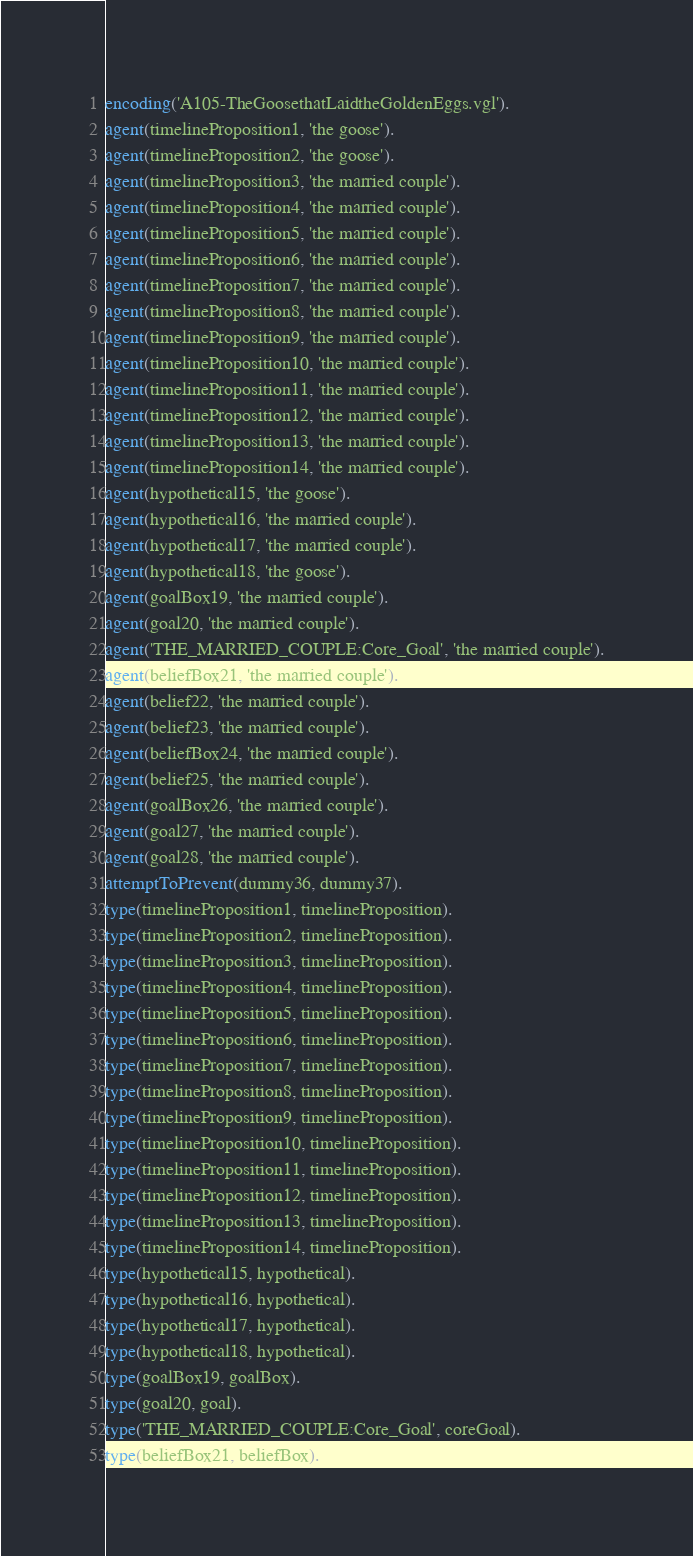<code> <loc_0><loc_0><loc_500><loc_500><_Prolog_>encoding('A105-TheGoosethatLaidtheGoldenEggs.vgl').
agent(timelineProposition1, 'the goose').
agent(timelineProposition2, 'the goose').
agent(timelineProposition3, 'the married couple').
agent(timelineProposition4, 'the married couple').
agent(timelineProposition5, 'the married couple').
agent(timelineProposition6, 'the married couple').
agent(timelineProposition7, 'the married couple').
agent(timelineProposition8, 'the married couple').
agent(timelineProposition9, 'the married couple').
agent(timelineProposition10, 'the married couple').
agent(timelineProposition11, 'the married couple').
agent(timelineProposition12, 'the married couple').
agent(timelineProposition13, 'the married couple').
agent(timelineProposition14, 'the married couple').
agent(hypothetical15, 'the goose').
agent(hypothetical16, 'the married couple').
agent(hypothetical17, 'the married couple').
agent(hypothetical18, 'the goose').
agent(goalBox19, 'the married couple').
agent(goal20, 'the married couple').
agent('THE_MARRIED_COUPLE:Core_Goal', 'the married couple').
agent(beliefBox21, 'the married couple').
agent(belief22, 'the married couple').
agent(belief23, 'the married couple').
agent(beliefBox24, 'the married couple').
agent(belief25, 'the married couple').
agent(goalBox26, 'the married couple').
agent(goal27, 'the married couple').
agent(goal28, 'the married couple').
attemptToPrevent(dummy36, dummy37).
type(timelineProposition1, timelineProposition).
type(timelineProposition2, timelineProposition).
type(timelineProposition3, timelineProposition).
type(timelineProposition4, timelineProposition).
type(timelineProposition5, timelineProposition).
type(timelineProposition6, timelineProposition).
type(timelineProposition7, timelineProposition).
type(timelineProposition8, timelineProposition).
type(timelineProposition9, timelineProposition).
type(timelineProposition10, timelineProposition).
type(timelineProposition11, timelineProposition).
type(timelineProposition12, timelineProposition).
type(timelineProposition13, timelineProposition).
type(timelineProposition14, timelineProposition).
type(hypothetical15, hypothetical).
type(hypothetical16, hypothetical).
type(hypothetical17, hypothetical).
type(hypothetical18, hypothetical).
type(goalBox19, goalBox).
type(goal20, goal).
type('THE_MARRIED_COUPLE:Core_Goal', coreGoal).
type(beliefBox21, beliefBox).</code> 